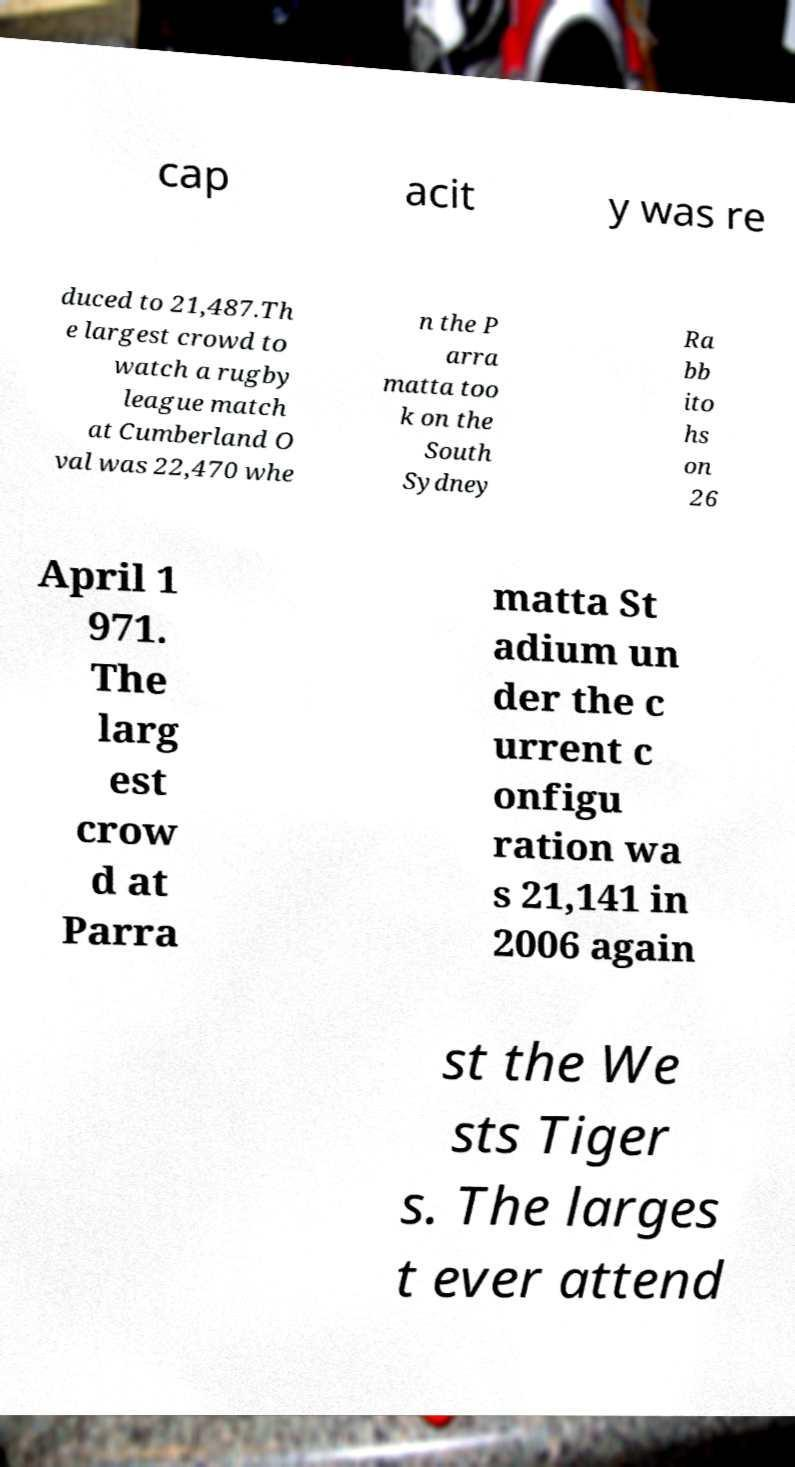Can you accurately transcribe the text from the provided image for me? cap acit y was re duced to 21,487.Th e largest crowd to watch a rugby league match at Cumberland O val was 22,470 whe n the P arra matta too k on the South Sydney Ra bb ito hs on 26 April 1 971. The larg est crow d at Parra matta St adium un der the c urrent c onfigu ration wa s 21,141 in 2006 again st the We sts Tiger s. The larges t ever attend 